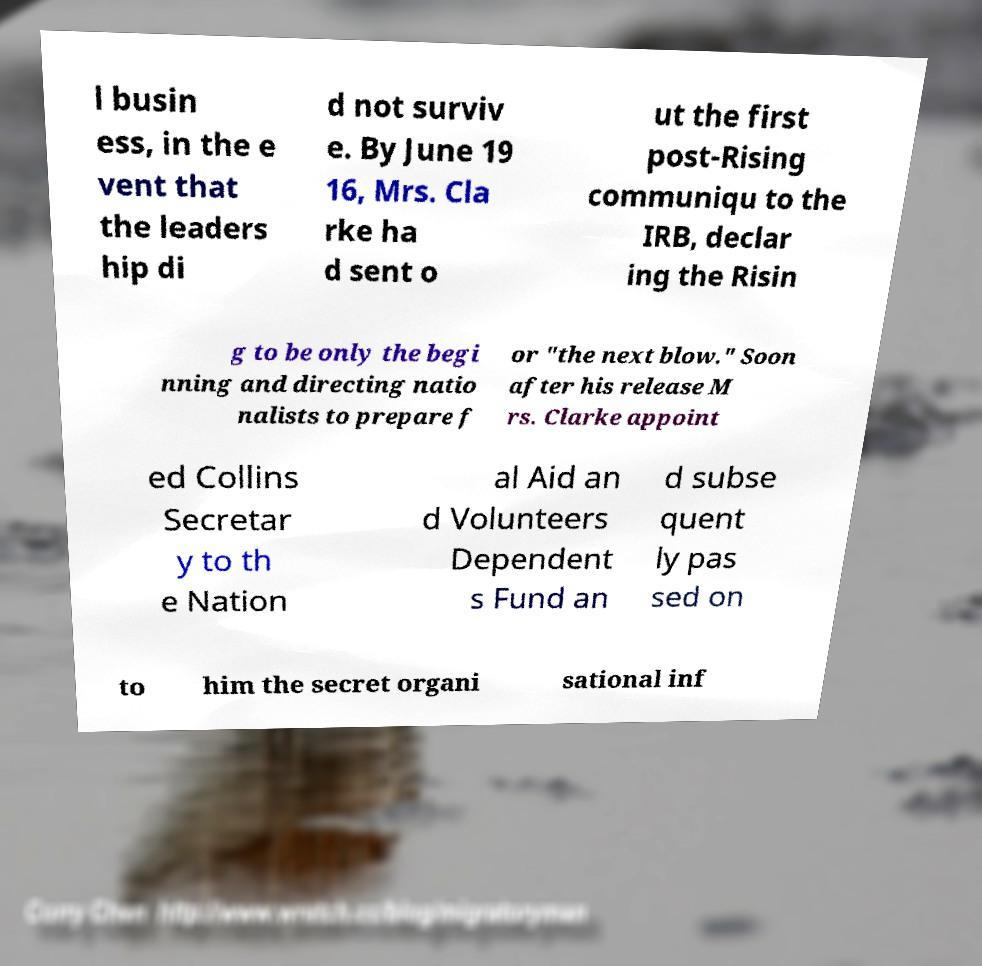Please identify and transcribe the text found in this image. l busin ess, in the e vent that the leaders hip di d not surviv e. By June 19 16, Mrs. Cla rke ha d sent o ut the first post-Rising communiqu to the IRB, declar ing the Risin g to be only the begi nning and directing natio nalists to prepare f or "the next blow." Soon after his release M rs. Clarke appoint ed Collins Secretar y to th e Nation al Aid an d Volunteers Dependent s Fund an d subse quent ly pas sed on to him the secret organi sational inf 